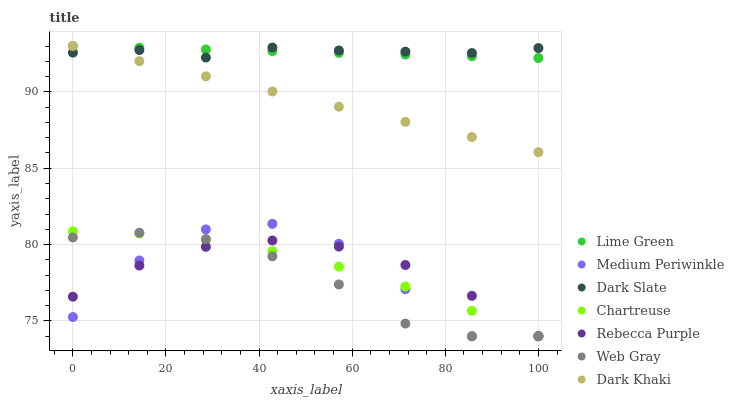Does Web Gray have the minimum area under the curve?
Answer yes or no. Yes. Does Dark Slate have the maximum area under the curve?
Answer yes or no. Yes. Does Medium Periwinkle have the minimum area under the curve?
Answer yes or no. No. Does Medium Periwinkle have the maximum area under the curve?
Answer yes or no. No. Is Lime Green the smoothest?
Answer yes or no. Yes. Is Medium Periwinkle the roughest?
Answer yes or no. Yes. Is Dark Khaki the smoothest?
Answer yes or no. No. Is Dark Khaki the roughest?
Answer yes or no. No. Does Web Gray have the lowest value?
Answer yes or no. Yes. Does Dark Khaki have the lowest value?
Answer yes or no. No. Does Lime Green have the highest value?
Answer yes or no. Yes. Does Medium Periwinkle have the highest value?
Answer yes or no. No. Is Rebecca Purple less than Dark Khaki?
Answer yes or no. Yes. Is Dark Khaki greater than Medium Periwinkle?
Answer yes or no. Yes. Does Rebecca Purple intersect Medium Periwinkle?
Answer yes or no. Yes. Is Rebecca Purple less than Medium Periwinkle?
Answer yes or no. No. Is Rebecca Purple greater than Medium Periwinkle?
Answer yes or no. No. Does Rebecca Purple intersect Dark Khaki?
Answer yes or no. No. 